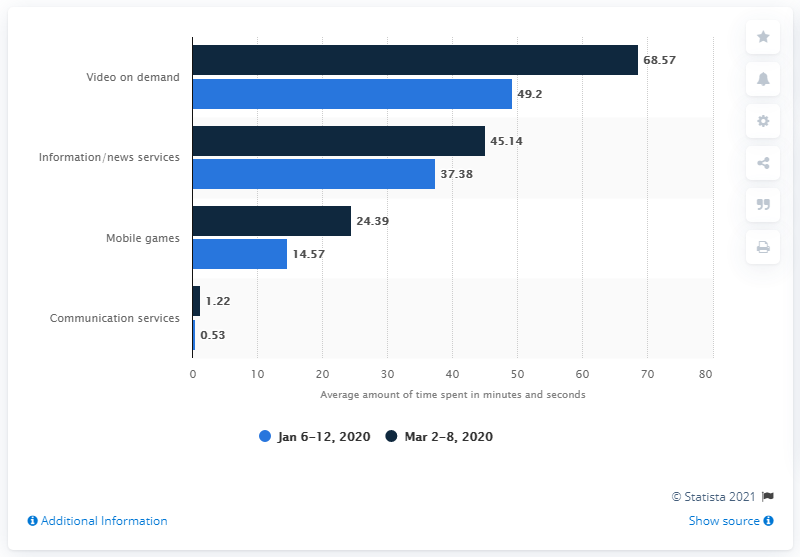Point out several critical features in this image. Between January and March 2020, communication services experienced the most significant growth. 